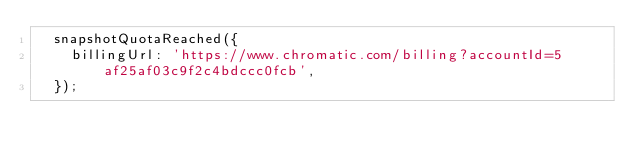Convert code to text. <code><loc_0><loc_0><loc_500><loc_500><_JavaScript_>  snapshotQuotaReached({
    billingUrl: 'https://www.chromatic.com/billing?accountId=5af25af03c9f2c4bdccc0fcb',
  });
</code> 